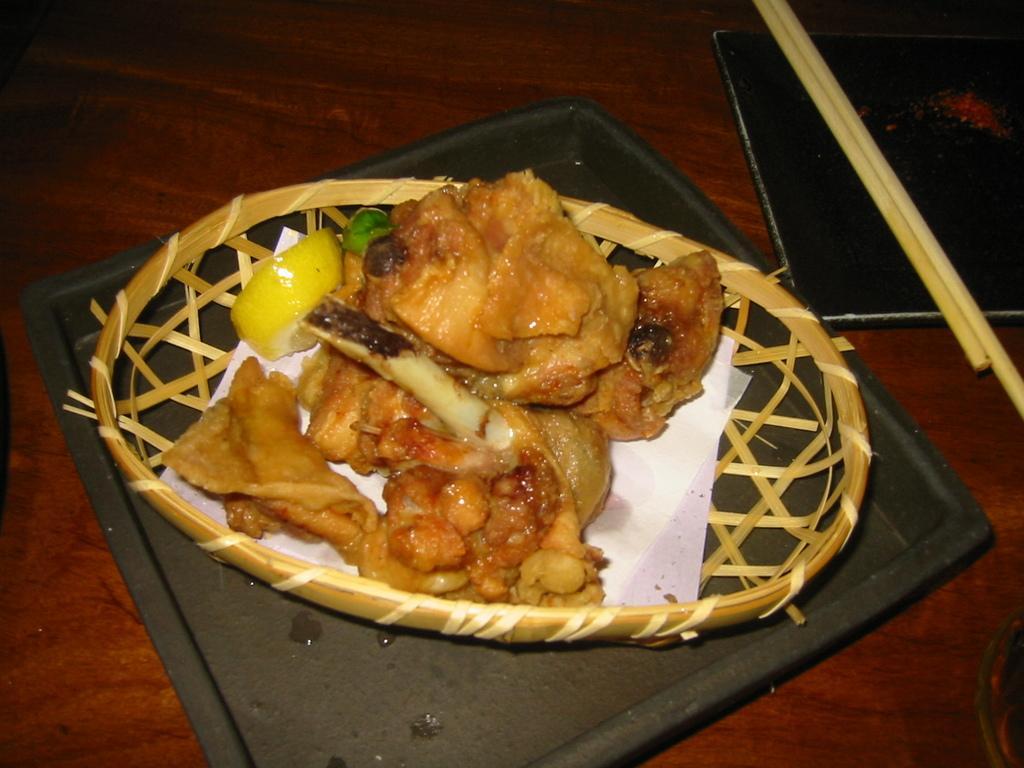How would you summarize this image in a sentence or two? In this picture I can see a food item with tissues in a basket, which is on the plate, there are chopsticks on the another plate, on the table. 